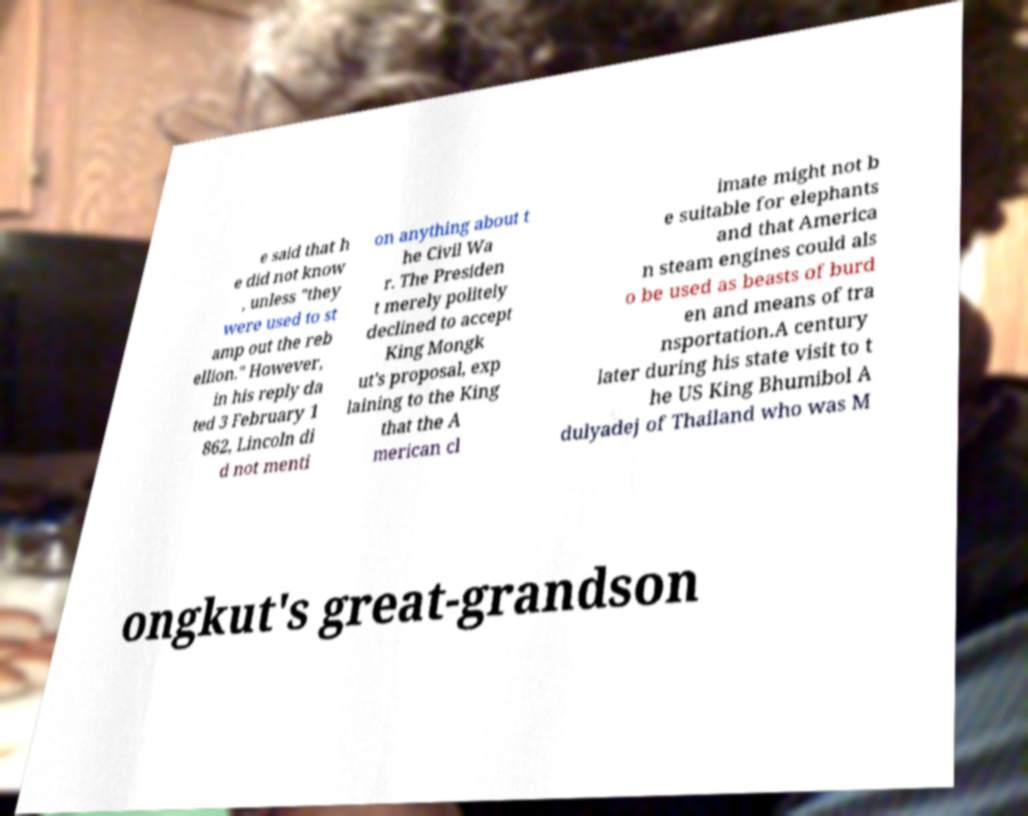Please read and relay the text visible in this image. What does it say? e said that h e did not know , unless "they were used to st amp out the reb ellion." However, in his reply da ted 3 February 1 862, Lincoln di d not menti on anything about t he Civil Wa r. The Presiden t merely politely declined to accept King Mongk ut's proposal, exp laining to the King that the A merican cl imate might not b e suitable for elephants and that America n steam engines could als o be used as beasts of burd en and means of tra nsportation.A century later during his state visit to t he US King Bhumibol A dulyadej of Thailand who was M ongkut's great-grandson 